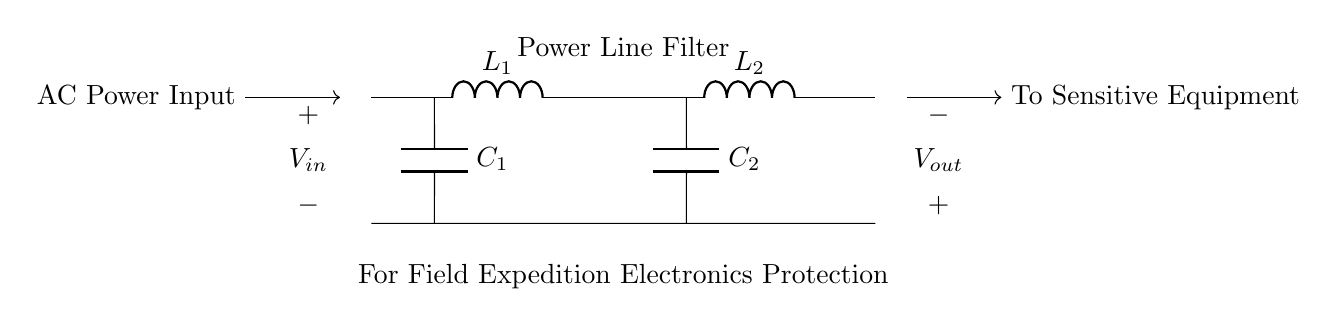What is the purpose of the circuit? The circuit is designed to filter power line noise to protect sensitive electronic devices during field expeditions. The diagram indicates its specific use through labeling.
Answer: Power Line Filter What types of components are used in this filter? The circuit contains inductors and capacitors, as indicated by the symbols L and C. The components are used for filtering different frequency components of the incoming AC power.
Answer: Inductors and capacitors How many inductors are in the circuit? There are two inductors present in the circuit, labeled L1 and L2, as shown in the diagram at distinct positions.
Answer: Two What is the input voltage labeled as? The input voltage is labeled as V_in, which represents the voltage entering the circuit to be filtered. This is specified at the left side of the diagram.
Answer: V_in What do the capacitors in this circuit do? The capacitors, C1 and C2, are used to block low-frequency noise and allow higher frequencies to pass, thus helping in the filtration process. Capacitors typically smooth out voltage fluctuations.
Answer: Filter noise How does the output voltage relate to the input voltage? The output voltage V_out will be a cleaner version of the input voltage V_in, having less noise and lower interference due to the filtering action of the inductors and capacitors.
Answer: Cleaner version of V_in 